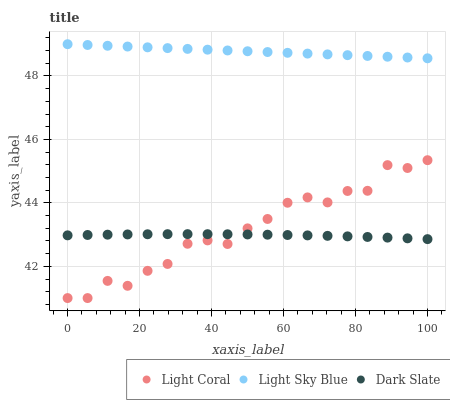Does Dark Slate have the minimum area under the curve?
Answer yes or no. Yes. Does Light Sky Blue have the maximum area under the curve?
Answer yes or no. Yes. Does Light Sky Blue have the minimum area under the curve?
Answer yes or no. No. Does Dark Slate have the maximum area under the curve?
Answer yes or no. No. Is Light Sky Blue the smoothest?
Answer yes or no. Yes. Is Light Coral the roughest?
Answer yes or no. Yes. Is Dark Slate the smoothest?
Answer yes or no. No. Is Dark Slate the roughest?
Answer yes or no. No. Does Light Coral have the lowest value?
Answer yes or no. Yes. Does Dark Slate have the lowest value?
Answer yes or no. No. Does Light Sky Blue have the highest value?
Answer yes or no. Yes. Does Dark Slate have the highest value?
Answer yes or no. No. Is Light Coral less than Light Sky Blue?
Answer yes or no. Yes. Is Light Sky Blue greater than Light Coral?
Answer yes or no. Yes. Does Light Coral intersect Dark Slate?
Answer yes or no. Yes. Is Light Coral less than Dark Slate?
Answer yes or no. No. Is Light Coral greater than Dark Slate?
Answer yes or no. No. Does Light Coral intersect Light Sky Blue?
Answer yes or no. No. 